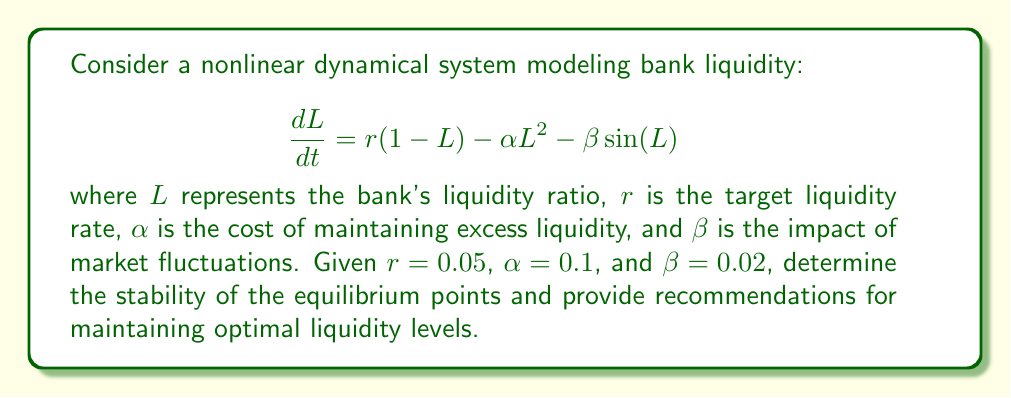Teach me how to tackle this problem. To analyze the stability of this nonlinear dynamical system, we follow these steps:

1) Find the equilibrium points by setting $\frac{dL}{dt} = 0$:

   $$0 = r(1-L) - \alpha L^2 - \beta \sin(L)$$
   $$0 = 0.05(1-L) - 0.1L^2 - 0.02\sin(L)$$

   This equation is transcendental and cannot be solved analytically. We can use numerical methods to find that there are two equilibrium points: $L_1 \approx 0.4395$ and $L_2 \approx 0.9605$.

2) Analyze the stability of each equilibrium point by finding the derivative of $\frac{dL}{dt}$ with respect to $L$:

   $$\frac{d}{dL}\left(\frac{dL}{dt}\right) = -r - 2\alpha L - \beta \cos(L)$$

3) Evaluate this derivative at each equilibrium point:

   At $L_1 \approx 0.4395$:
   $$-0.05 - 2(0.1)(0.4395) - 0.02\cos(0.4395) \approx -0.1366 < 0$$

   At $L_2 \approx 0.9605$:
   $$-0.05 - 2(0.1)(0.9605) - 0.02\cos(0.9605) \approx 0.0823 > 0$$

4) Interpret the results:
   - $L_1 \approx 0.4395$ is a stable equilibrium point because the derivative is negative.
   - $L_2 \approx 0.9605$ is an unstable equilibrium point because the derivative is positive.

5) Recommendations for maintaining optimal liquidity levels:
   - The bank should aim to maintain its liquidity ratio close to the stable equilibrium point of 43.95%.
   - If the liquidity ratio falls below this level, the bank should increase its liquid assets.
   - If the liquidity ratio rises above this level, the bank can safely reduce its liquid assets or increase investments.
   - The bank should avoid approaching the unstable equilibrium point of 96.05%, as any deviation from this point will lead to rapid changes in liquidity.
Answer: The system has a stable equilibrium at $L \approx 0.4395$ and an unstable equilibrium at $L \approx 0.9605$. Maintain liquidity near 43.95% for optimal stability. 